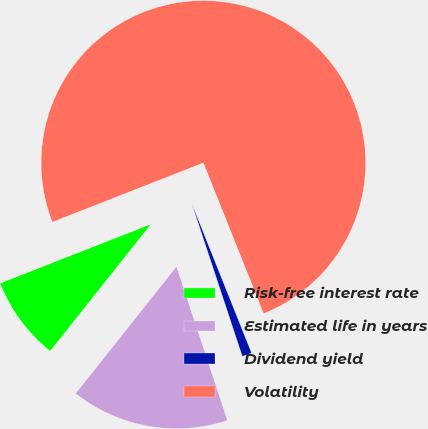<chart> <loc_0><loc_0><loc_500><loc_500><pie_chart><fcel>Risk-free interest rate<fcel>Estimated life in years<fcel>Dividend yield<fcel>Volatility<nl><fcel>8.37%<fcel>15.77%<fcel>0.97%<fcel>74.9%<nl></chart> 